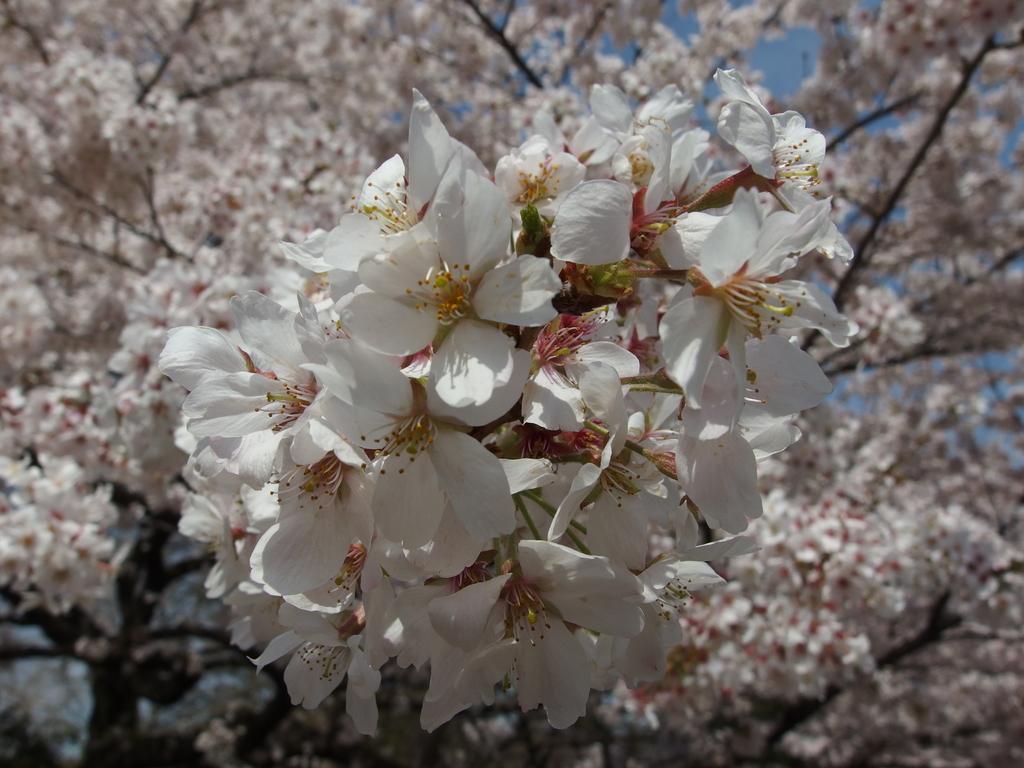Please provide a concise description of this image. In this picture we can see white color flowers and few trees. 